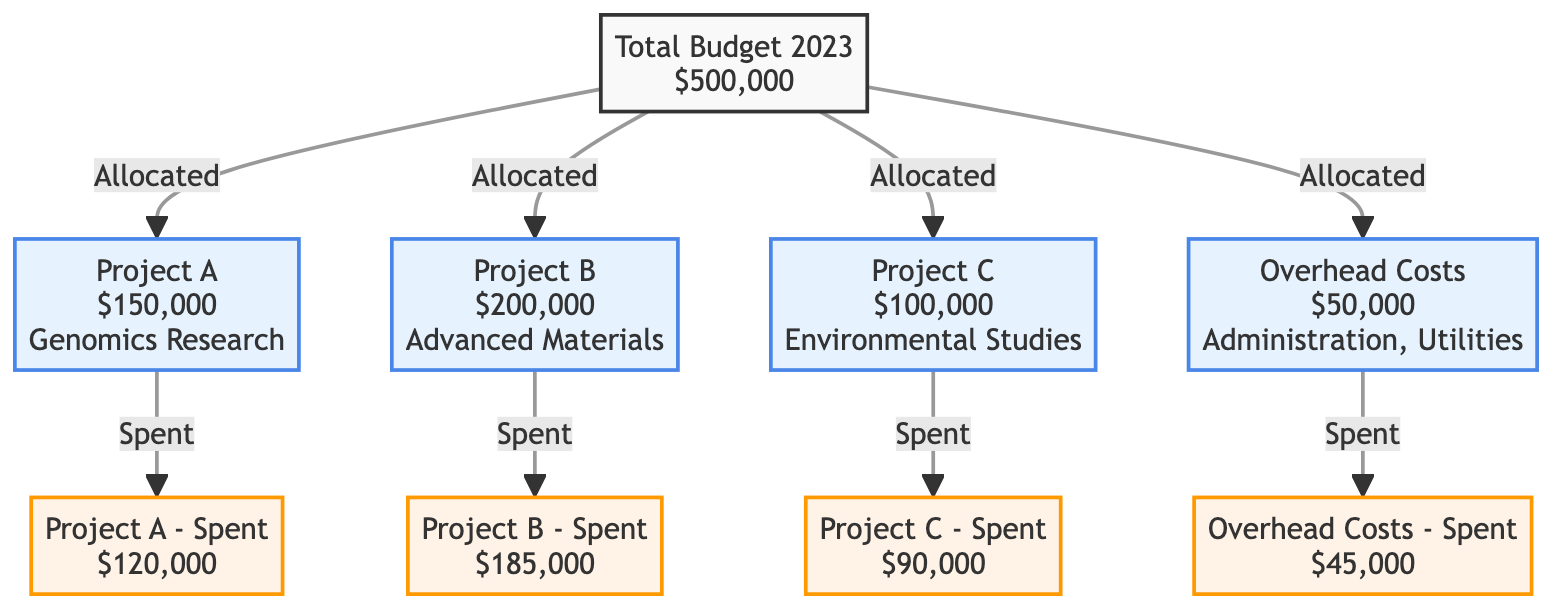What's the total budget for 2023? The diagram explicitly states the total budget for 2023 as $500,000 in the first node.
Answer: $500,000 How much is allocated for Project B? Project B is allocated $200,000 as indicated in the node describing Project B.
Answer: $200,000 What is the total spent amount on overhead costs? The diagram shows that $45,000 has been spent on overhead costs, as indicated in the node for "Overhead Costs - Spent."
Answer: $45,000 How much more has been spent on Project B than Project C? Project B has spent $185,000 while Project C has spent $90,000. The difference is calculated as $185,000 - $90,000 = $95,000.
Answer: $95,000 What is the total amount spent across all projects and overhead costs? The spent amounts are $120,000 for Project A, $185,000 for Project B, $90,000 for Project C, and $45,000 for overhead. Adding these gives $120,000 + $185,000 + $90,000 + $45,000 = $440,000.
Answer: $440,000 Which project has the highest spending? Comparing the spent amounts, Project B at $185,000 has the highest spending compared to Project A at $120,000 and Project C at $90,000.
Answer: Project B What percentage of the total budget has been spent? The total spent amount is $440,000 out of a $500,000 budget. Calculating the percentage gives ($440,000 / $500,000) * 100 = 88%.
Answer: 88% How many projects are there in total? The diagram includes three distinct projects: Project A, Project B, and Project C. Counting these, we find there are three projects.
Answer: 3 What is the relationship between total budget and the sum of allocated budgets for projects? The total budget of $500,000 equals the sum of allocated budgets for three projects ($150,000 + $200,000 + $100,000) plus overhead costs ($50,000), which adds up to $500,000. This shows a direct relationship.
Answer: Equal 